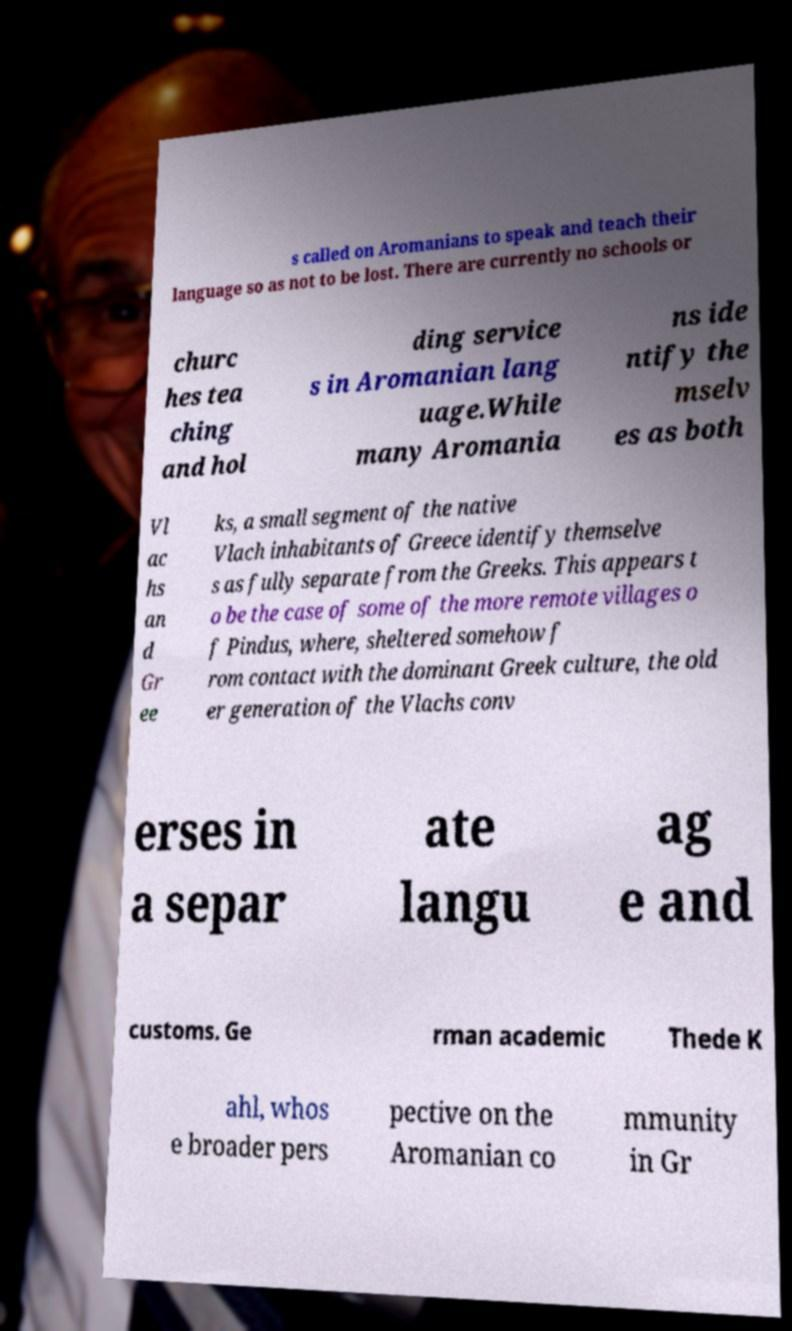For documentation purposes, I need the text within this image transcribed. Could you provide that? s called on Aromanians to speak and teach their language so as not to be lost. There are currently no schools or churc hes tea ching and hol ding service s in Aromanian lang uage.While many Aromania ns ide ntify the mselv es as both Vl ac hs an d Gr ee ks, a small segment of the native Vlach inhabitants of Greece identify themselve s as fully separate from the Greeks. This appears t o be the case of some of the more remote villages o f Pindus, where, sheltered somehow f rom contact with the dominant Greek culture, the old er generation of the Vlachs conv erses in a separ ate langu ag e and customs. Ge rman academic Thede K ahl, whos e broader pers pective on the Aromanian co mmunity in Gr 